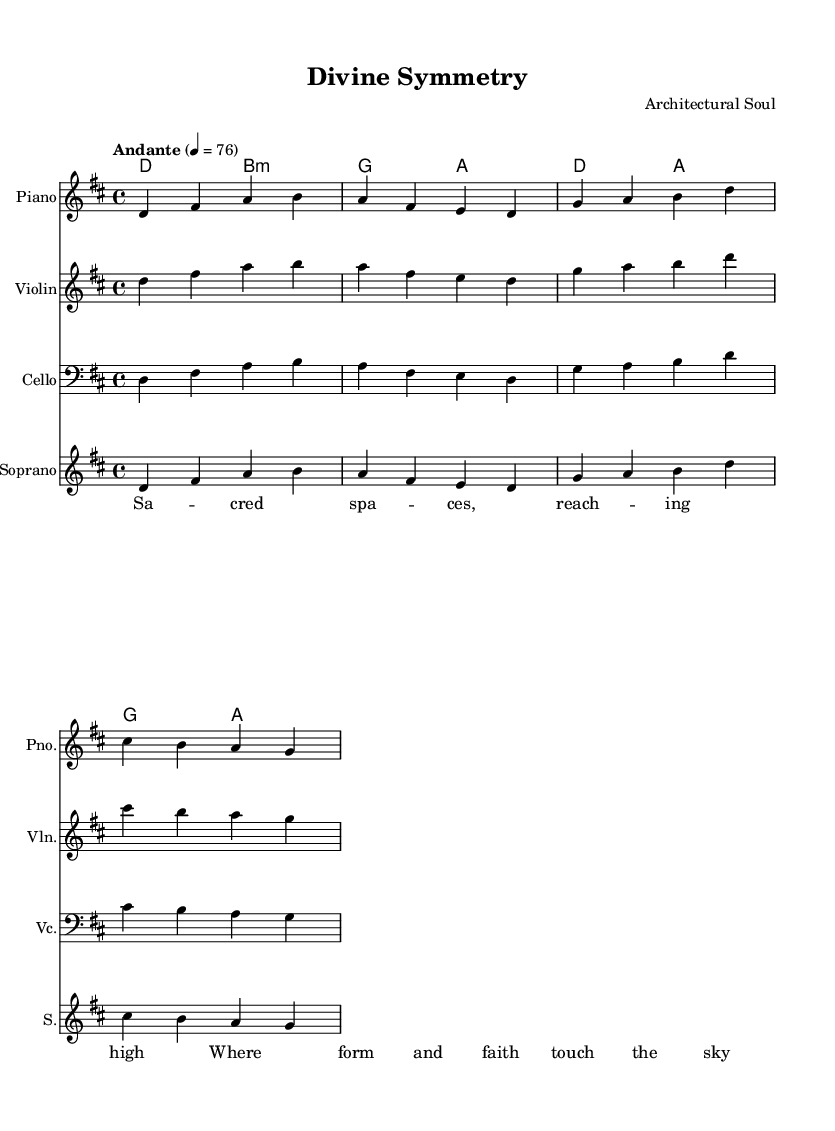What is the key signature of this music? The key signature is D major, which contains two sharps (F# and C#) as indicated at the beginning of the staff.
Answer: D major What is the time signature of this music? The time signature is 4/4, which can be identified by the "4" over "4" at the beginning of the staff, indicating four beats per measure.
Answer: 4/4 What is the tempo marking of the piece? The tempo marking is "Andante" with a metronome marking of quarter note = 76, suggesting a moderately slow tempo for the performance.
Answer: Andante 4 = 76 How many measures are in the melody section? The melody contains a total of 8 measures, which can be counted by observing the bars in the written notation.
Answer: 8 What are the lyrical themes suggested by the lyrics? The lyrics "Sacred spaces, reaching high" indicate a theme of spirituality and the relationship between space and the transcendent, suggesting a connection to religious or spiritual architecture.
Answer: Spirituality What instruments are indicated in this score? The score features a piano, violin, and cello for the instrumental parts, alongside a soprano for the vocal line indicated in the choir staff.
Answer: Piano, Violin, Cello, Soprano What is the purpose of the chord names in the music? The chord names in the score provide harmonic support and guide the performers on how to accompany the melody, adding depth and texture to the piece, which is significant in religious music settings.
Answer: Harmonic support 